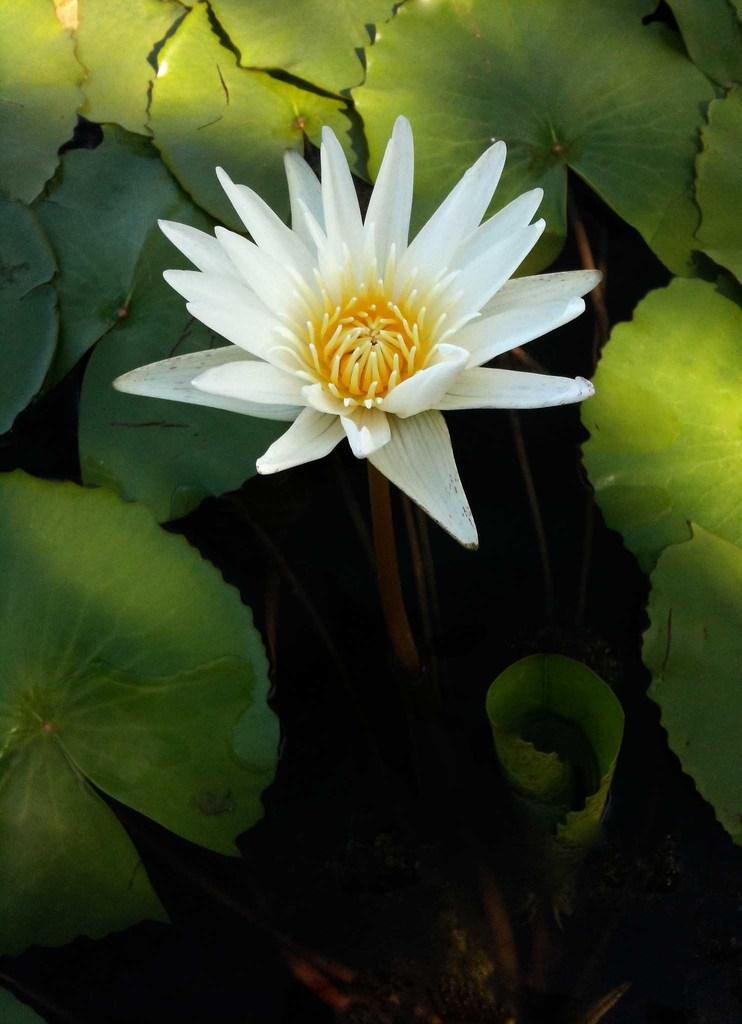What type of plants are visible in the image? There are colorful flowers and green leaves in the image. Can you describe the colors of the flowers? The flowers are colorful, but the specific colors are not mentioned in the facts. What is the color of the leaves in the image? The leaves in the image are green. How many houses can be seen in the image? There are no houses present in the image; it features colorful flowers and green leaves. Are there any horses visible in the image? There are no horses present in the image. 